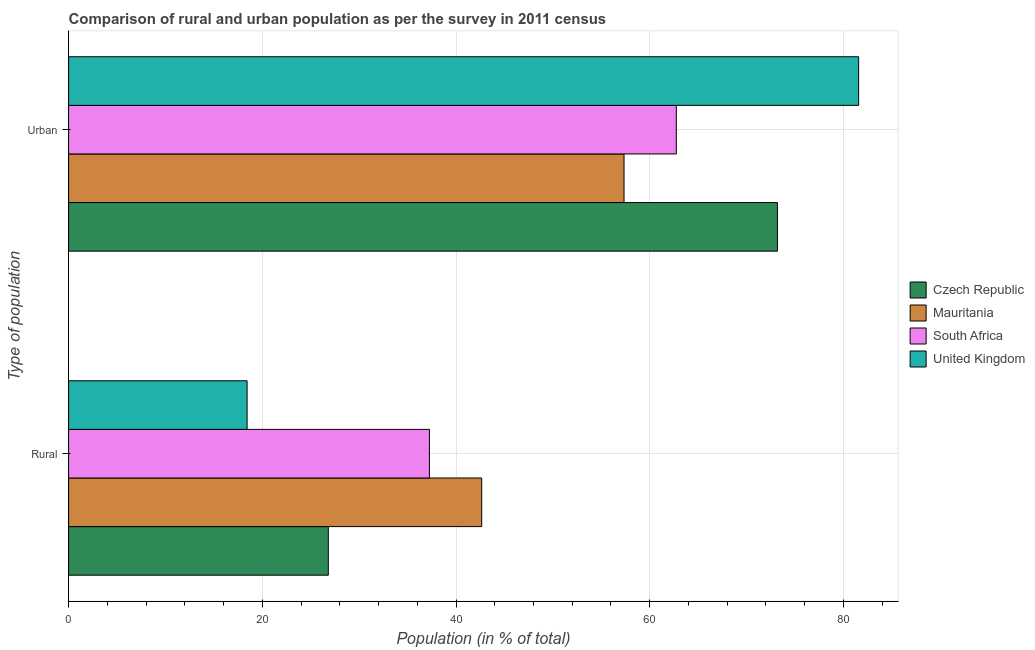Are the number of bars per tick equal to the number of legend labels?
Offer a terse response. Yes. Are the number of bars on each tick of the Y-axis equal?
Ensure brevity in your answer.  Yes. How many bars are there on the 2nd tick from the bottom?
Provide a succinct answer. 4. What is the label of the 1st group of bars from the top?
Give a very brief answer. Urban. What is the urban population in Czech Republic?
Keep it short and to the point. 73.19. Across all countries, what is the maximum rural population?
Offer a terse response. 42.65. Across all countries, what is the minimum urban population?
Your response must be concise. 57.35. In which country was the rural population maximum?
Keep it short and to the point. Mauritania. In which country was the urban population minimum?
Give a very brief answer. Mauritania. What is the total urban population in the graph?
Provide a short and direct response. 274.85. What is the difference between the urban population in Mauritania and that in United Kingdom?
Your answer should be very brief. -24.22. What is the difference between the rural population in United Kingdom and the urban population in South Africa?
Keep it short and to the point. -44.32. What is the average rural population per country?
Ensure brevity in your answer.  31.29. What is the difference between the urban population and rural population in Mauritania?
Provide a succinct answer. 14.7. In how many countries, is the urban population greater than 4 %?
Offer a very short reply. 4. What is the ratio of the urban population in South Africa to that in Mauritania?
Provide a succinct answer. 1.09. Is the rural population in South Africa less than that in United Kingdom?
Give a very brief answer. No. In how many countries, is the urban population greater than the average urban population taken over all countries?
Provide a short and direct response. 2. What does the 3rd bar from the top in Urban represents?
Provide a succinct answer. Mauritania. What does the 1st bar from the bottom in Urban represents?
Offer a very short reply. Czech Republic. What is the difference between two consecutive major ticks on the X-axis?
Your answer should be very brief. 20. Are the values on the major ticks of X-axis written in scientific E-notation?
Keep it short and to the point. No. Does the graph contain any zero values?
Give a very brief answer. No. Where does the legend appear in the graph?
Offer a very short reply. Center right. What is the title of the graph?
Offer a very short reply. Comparison of rural and urban population as per the survey in 2011 census. What is the label or title of the X-axis?
Your answer should be very brief. Population (in % of total). What is the label or title of the Y-axis?
Make the answer very short. Type of population. What is the Population (in % of total) in Czech Republic in Rural?
Offer a very short reply. 26.82. What is the Population (in % of total) in Mauritania in Rural?
Keep it short and to the point. 42.65. What is the Population (in % of total) in South Africa in Rural?
Your answer should be very brief. 37.25. What is the Population (in % of total) in United Kingdom in Rural?
Offer a very short reply. 18.43. What is the Population (in % of total) in Czech Republic in Urban?
Provide a succinct answer. 73.19. What is the Population (in % of total) in Mauritania in Urban?
Give a very brief answer. 57.35. What is the Population (in % of total) of South Africa in Urban?
Make the answer very short. 62.75. What is the Population (in % of total) of United Kingdom in Urban?
Provide a succinct answer. 81.57. Across all Type of population, what is the maximum Population (in % of total) of Czech Republic?
Provide a short and direct response. 73.19. Across all Type of population, what is the maximum Population (in % of total) in Mauritania?
Make the answer very short. 57.35. Across all Type of population, what is the maximum Population (in % of total) in South Africa?
Provide a short and direct response. 62.75. Across all Type of population, what is the maximum Population (in % of total) of United Kingdom?
Offer a very short reply. 81.57. Across all Type of population, what is the minimum Population (in % of total) in Czech Republic?
Offer a very short reply. 26.82. Across all Type of population, what is the minimum Population (in % of total) of Mauritania?
Provide a short and direct response. 42.65. Across all Type of population, what is the minimum Population (in % of total) in South Africa?
Ensure brevity in your answer.  37.25. Across all Type of population, what is the minimum Population (in % of total) in United Kingdom?
Your answer should be compact. 18.43. What is the total Population (in % of total) of Czech Republic in the graph?
Make the answer very short. 100. What is the total Population (in % of total) of Mauritania in the graph?
Keep it short and to the point. 100. What is the total Population (in % of total) of South Africa in the graph?
Offer a very short reply. 100. What is the difference between the Population (in % of total) of Czech Republic in Rural and that in Urban?
Your response must be concise. -46.37. What is the difference between the Population (in % of total) in Mauritania in Rural and that in Urban?
Your answer should be very brief. -14.7. What is the difference between the Population (in % of total) in South Africa in Rural and that in Urban?
Keep it short and to the point. -25.49. What is the difference between the Population (in % of total) of United Kingdom in Rural and that in Urban?
Give a very brief answer. -63.14. What is the difference between the Population (in % of total) of Czech Republic in Rural and the Population (in % of total) of Mauritania in Urban?
Provide a succinct answer. -30.53. What is the difference between the Population (in % of total) of Czech Republic in Rural and the Population (in % of total) of South Africa in Urban?
Offer a terse response. -35.93. What is the difference between the Population (in % of total) in Czech Republic in Rural and the Population (in % of total) in United Kingdom in Urban?
Offer a terse response. -54.76. What is the difference between the Population (in % of total) in Mauritania in Rural and the Population (in % of total) in South Africa in Urban?
Your answer should be compact. -20.09. What is the difference between the Population (in % of total) of Mauritania in Rural and the Population (in % of total) of United Kingdom in Urban?
Offer a very short reply. -38.92. What is the difference between the Population (in % of total) of South Africa in Rural and the Population (in % of total) of United Kingdom in Urban?
Ensure brevity in your answer.  -44.32. What is the average Population (in % of total) in Mauritania per Type of population?
Offer a terse response. 50. What is the average Population (in % of total) of United Kingdom per Type of population?
Offer a very short reply. 50. What is the difference between the Population (in % of total) in Czech Republic and Population (in % of total) in Mauritania in Rural?
Your answer should be compact. -15.84. What is the difference between the Population (in % of total) in Czech Republic and Population (in % of total) in South Africa in Rural?
Provide a short and direct response. -10.44. What is the difference between the Population (in % of total) of Czech Republic and Population (in % of total) of United Kingdom in Rural?
Your answer should be compact. 8.38. What is the difference between the Population (in % of total) in Mauritania and Population (in % of total) in South Africa in Rural?
Ensure brevity in your answer.  5.4. What is the difference between the Population (in % of total) of Mauritania and Population (in % of total) of United Kingdom in Rural?
Give a very brief answer. 24.22. What is the difference between the Population (in % of total) in South Africa and Population (in % of total) in United Kingdom in Rural?
Keep it short and to the point. 18.82. What is the difference between the Population (in % of total) in Czech Republic and Population (in % of total) in Mauritania in Urban?
Make the answer very short. 15.84. What is the difference between the Population (in % of total) in Czech Republic and Population (in % of total) in South Africa in Urban?
Give a very brief answer. 10.44. What is the difference between the Population (in % of total) in Czech Republic and Population (in % of total) in United Kingdom in Urban?
Your answer should be very brief. -8.38. What is the difference between the Population (in % of total) in Mauritania and Population (in % of total) in South Africa in Urban?
Make the answer very short. -5.4. What is the difference between the Population (in % of total) in Mauritania and Population (in % of total) in United Kingdom in Urban?
Your answer should be very brief. -24.22. What is the difference between the Population (in % of total) in South Africa and Population (in % of total) in United Kingdom in Urban?
Provide a succinct answer. -18.82. What is the ratio of the Population (in % of total) of Czech Republic in Rural to that in Urban?
Provide a succinct answer. 0.37. What is the ratio of the Population (in % of total) in Mauritania in Rural to that in Urban?
Your response must be concise. 0.74. What is the ratio of the Population (in % of total) of South Africa in Rural to that in Urban?
Your response must be concise. 0.59. What is the ratio of the Population (in % of total) in United Kingdom in Rural to that in Urban?
Your answer should be very brief. 0.23. What is the difference between the highest and the second highest Population (in % of total) of Czech Republic?
Keep it short and to the point. 46.37. What is the difference between the highest and the second highest Population (in % of total) of Mauritania?
Provide a short and direct response. 14.7. What is the difference between the highest and the second highest Population (in % of total) of South Africa?
Your answer should be very brief. 25.49. What is the difference between the highest and the second highest Population (in % of total) of United Kingdom?
Offer a very short reply. 63.14. What is the difference between the highest and the lowest Population (in % of total) in Czech Republic?
Your answer should be compact. 46.37. What is the difference between the highest and the lowest Population (in % of total) of Mauritania?
Offer a terse response. 14.7. What is the difference between the highest and the lowest Population (in % of total) of South Africa?
Make the answer very short. 25.49. What is the difference between the highest and the lowest Population (in % of total) in United Kingdom?
Make the answer very short. 63.14. 